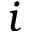<formula> <loc_0><loc_0><loc_500><loc_500>i</formula> 